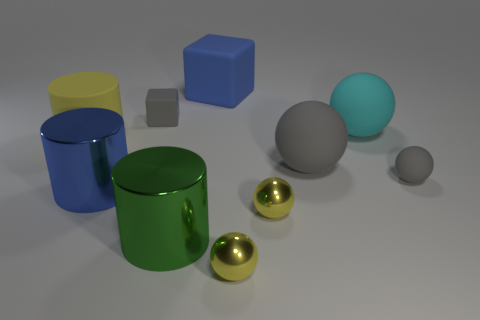Subtract all green metallic cylinders. How many cylinders are left? 2 Subtract all gray spheres. How many spheres are left? 3 Subtract all brown cylinders. How many gray spheres are left? 2 Subtract all blocks. How many objects are left? 8 Subtract 1 cylinders. How many cylinders are left? 2 Subtract all cyan balls. Subtract all purple cylinders. How many balls are left? 4 Subtract all big gray matte spheres. Subtract all big gray things. How many objects are left? 8 Add 3 blocks. How many blocks are left? 5 Add 7 small yellow spheres. How many small yellow spheres exist? 9 Subtract 0 cyan cylinders. How many objects are left? 10 